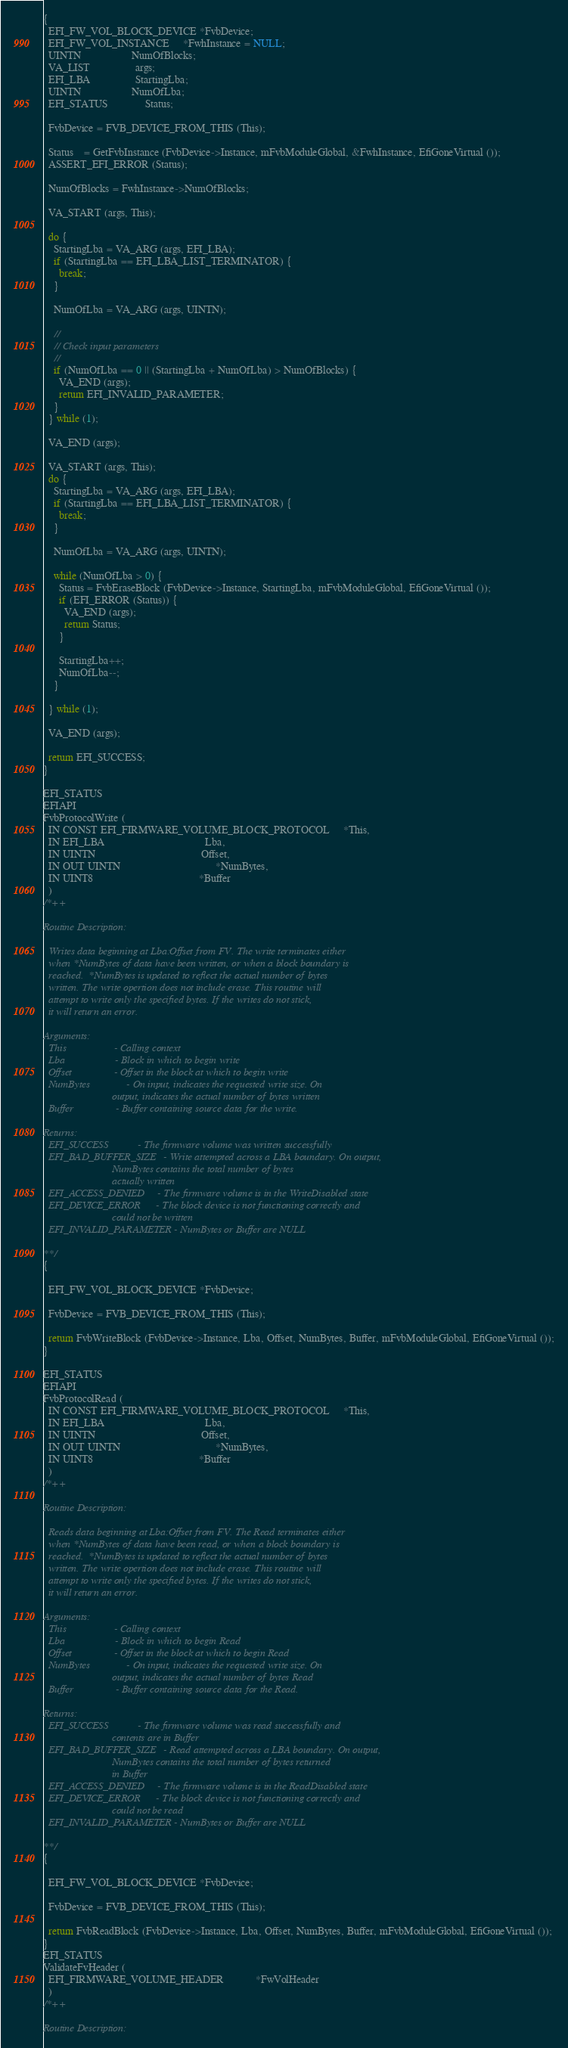<code> <loc_0><loc_0><loc_500><loc_500><_C_>{
  EFI_FW_VOL_BLOCK_DEVICE *FvbDevice;
  EFI_FW_VOL_INSTANCE     *FwhInstance = NULL;
  UINTN                   NumOfBlocks;
  VA_LIST                 args;
  EFI_LBA                 StartingLba;
  UINTN                   NumOfLba;
  EFI_STATUS              Status;

  FvbDevice = FVB_DEVICE_FROM_THIS (This);

  Status    = GetFvbInstance (FvbDevice->Instance, mFvbModuleGlobal, &FwhInstance, EfiGoneVirtual ());
  ASSERT_EFI_ERROR (Status);

  NumOfBlocks = FwhInstance->NumOfBlocks;

  VA_START (args, This);

  do {
    StartingLba = VA_ARG (args, EFI_LBA);
    if (StartingLba == EFI_LBA_LIST_TERMINATOR) {
      break;
    }

    NumOfLba = VA_ARG (args, UINTN);

    //
    // Check input parameters
    //
    if (NumOfLba == 0 || (StartingLba + NumOfLba) > NumOfBlocks) {
      VA_END (args);
      return EFI_INVALID_PARAMETER;
    }
  } while (1);

  VA_END (args);

  VA_START (args, This);
  do {
    StartingLba = VA_ARG (args, EFI_LBA);
    if (StartingLba == EFI_LBA_LIST_TERMINATOR) {
      break;
    }

    NumOfLba = VA_ARG (args, UINTN);

    while (NumOfLba > 0) {
      Status = FvbEraseBlock (FvbDevice->Instance, StartingLba, mFvbModuleGlobal, EfiGoneVirtual ());
      if (EFI_ERROR (Status)) {
        VA_END (args);
        return Status;
      }

      StartingLba++;
      NumOfLba--;
    }

  } while (1);

  VA_END (args);

  return EFI_SUCCESS;
}

EFI_STATUS
EFIAPI
FvbProtocolWrite (
  IN CONST EFI_FIRMWARE_VOLUME_BLOCK_PROTOCOL     *This,
  IN EFI_LBA                                      Lba,
  IN UINTN                                        Offset,
  IN OUT UINTN                                    *NumBytes,
  IN UINT8                                        *Buffer
  )
/*++

Routine Description:

  Writes data beginning at Lba:Offset from FV. The write terminates either
  when *NumBytes of data have been written, or when a block boundary is
  reached.  *NumBytes is updated to reflect the actual number of bytes
  written. The write opertion does not include erase. This routine will
  attempt to write only the specified bytes. If the writes do not stick,
  it will return an error.

Arguments:
  This                  - Calling context
  Lba                   - Block in which to begin write
  Offset                - Offset in the block at which to begin write
  NumBytes              - On input, indicates the requested write size. On
                          output, indicates the actual number of bytes written
  Buffer                - Buffer containing source data for the write.

Returns:
  EFI_SUCCESS           - The firmware volume was written successfully
  EFI_BAD_BUFFER_SIZE   - Write attempted across a LBA boundary. On output,
                          NumBytes contains the total number of bytes
                          actually written
  EFI_ACCESS_DENIED     - The firmware volume is in the WriteDisabled state
  EFI_DEVICE_ERROR      - The block device is not functioning correctly and
                          could not be written
  EFI_INVALID_PARAMETER - NumBytes or Buffer are NULL

**/
{

  EFI_FW_VOL_BLOCK_DEVICE *FvbDevice;

  FvbDevice = FVB_DEVICE_FROM_THIS (This);

  return FvbWriteBlock (FvbDevice->Instance, Lba, Offset, NumBytes, Buffer, mFvbModuleGlobal, EfiGoneVirtual ());
}

EFI_STATUS
EFIAPI
FvbProtocolRead (
  IN CONST EFI_FIRMWARE_VOLUME_BLOCK_PROTOCOL     *This,
  IN EFI_LBA                                      Lba,
  IN UINTN                                        Offset,
  IN OUT UINTN                                    *NumBytes,
  IN UINT8                                        *Buffer
  )
/*++

Routine Description:

  Reads data beginning at Lba:Offset from FV. The Read terminates either
  when *NumBytes of data have been read, or when a block boundary is
  reached.  *NumBytes is updated to reflect the actual number of bytes
  written. The write opertion does not include erase. This routine will
  attempt to write only the specified bytes. If the writes do not stick,
  it will return an error.

Arguments:
  This                  - Calling context
  Lba                   - Block in which to begin Read
  Offset                - Offset in the block at which to begin Read
  NumBytes              - On input, indicates the requested write size. On
                          output, indicates the actual number of bytes Read
  Buffer                - Buffer containing source data for the Read.

Returns:
  EFI_SUCCESS           - The firmware volume was read successfully and
                          contents are in Buffer
  EFI_BAD_BUFFER_SIZE   - Read attempted across a LBA boundary. On output,
                          NumBytes contains the total number of bytes returned
                          in Buffer
  EFI_ACCESS_DENIED     - The firmware volume is in the ReadDisabled state
  EFI_DEVICE_ERROR      - The block device is not functioning correctly and
                          could not be read
  EFI_INVALID_PARAMETER - NumBytes or Buffer are NULL

**/
{

  EFI_FW_VOL_BLOCK_DEVICE *FvbDevice;

  FvbDevice = FVB_DEVICE_FROM_THIS (This);

  return FvbReadBlock (FvbDevice->Instance, Lba, Offset, NumBytes, Buffer, mFvbModuleGlobal, EfiGoneVirtual ());
}
EFI_STATUS
ValidateFvHeader (
  EFI_FIRMWARE_VOLUME_HEADER            *FwVolHeader
  )
/*++

Routine Description:</code> 